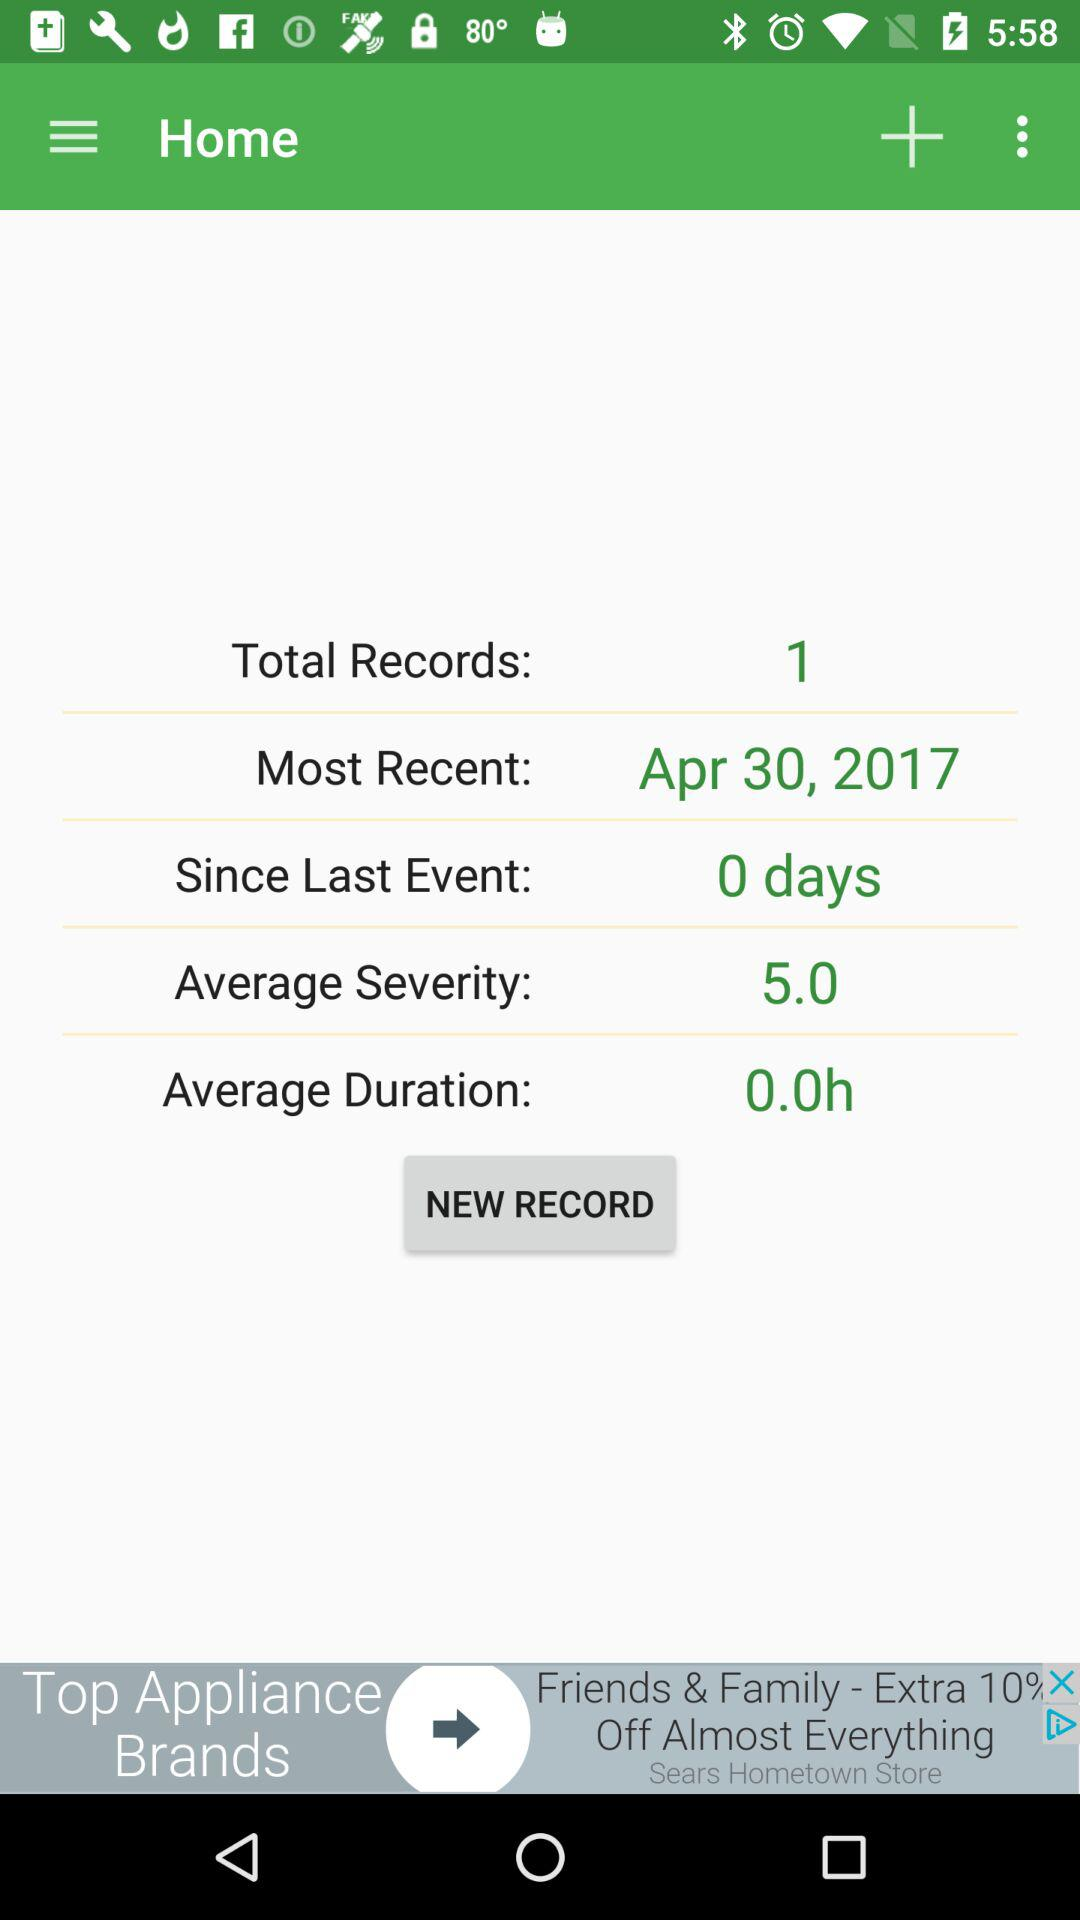What is the mentioned date for the most recent event? The mentioned date for the most recent event is April 30, 2017. 